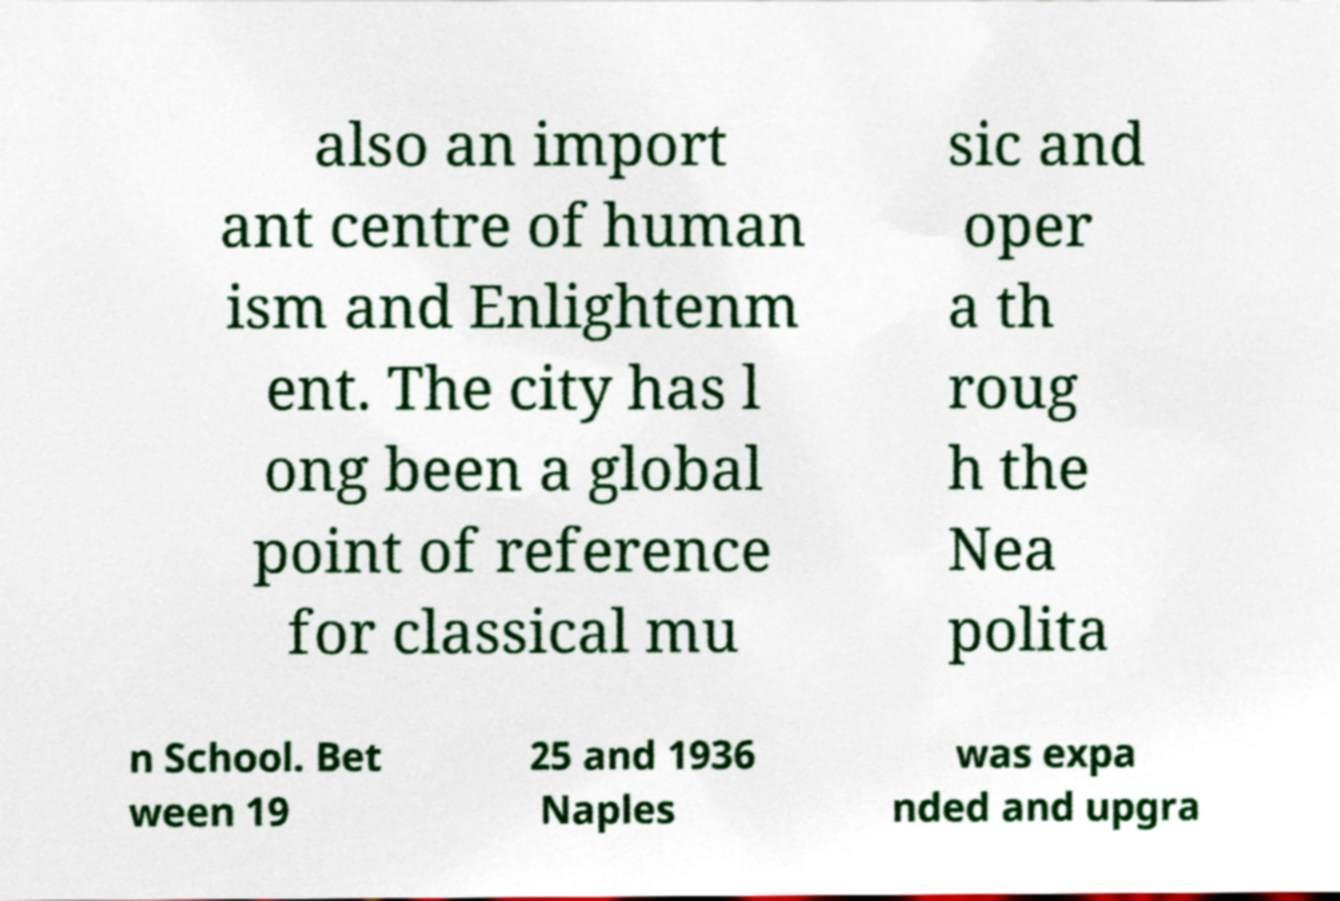Could you assist in decoding the text presented in this image and type it out clearly? also an import ant centre of human ism and Enlightenm ent. The city has l ong been a global point of reference for classical mu sic and oper a th roug h the Nea polita n School. Bet ween 19 25 and 1936 Naples was expa nded and upgra 